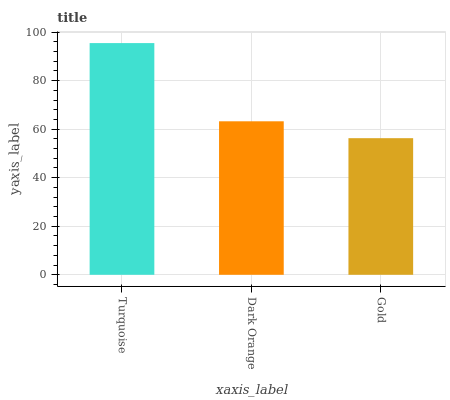Is Gold the minimum?
Answer yes or no. Yes. Is Turquoise the maximum?
Answer yes or no. Yes. Is Dark Orange the minimum?
Answer yes or no. No. Is Dark Orange the maximum?
Answer yes or no. No. Is Turquoise greater than Dark Orange?
Answer yes or no. Yes. Is Dark Orange less than Turquoise?
Answer yes or no. Yes. Is Dark Orange greater than Turquoise?
Answer yes or no. No. Is Turquoise less than Dark Orange?
Answer yes or no. No. Is Dark Orange the high median?
Answer yes or no. Yes. Is Dark Orange the low median?
Answer yes or no. Yes. Is Gold the high median?
Answer yes or no. No. Is Turquoise the low median?
Answer yes or no. No. 